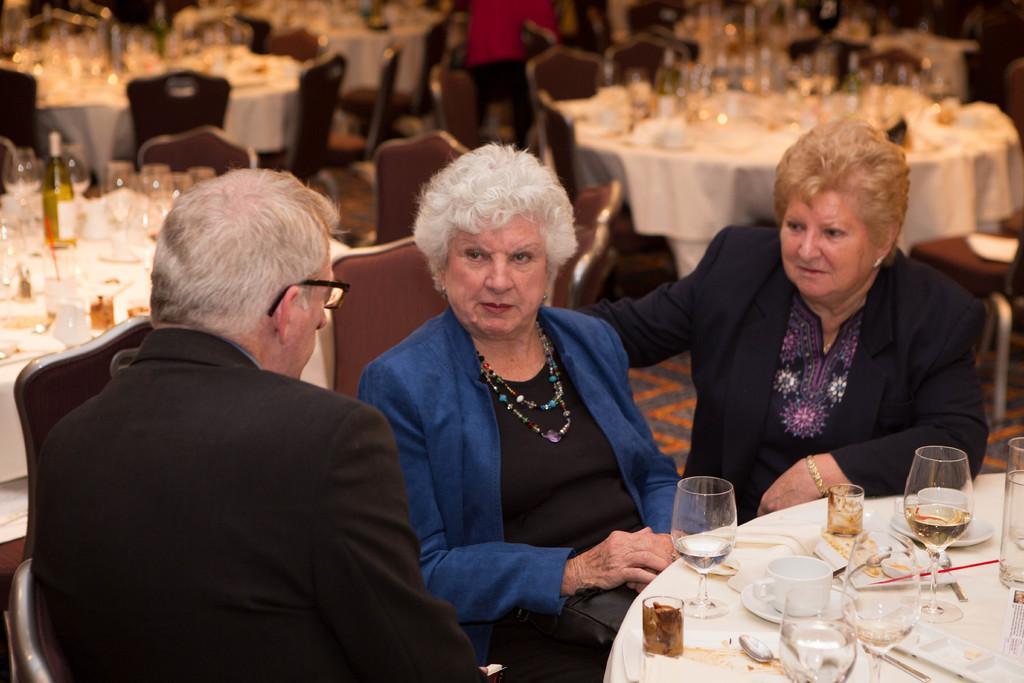Please provide a concise description of this image. In the image I can see few people siting on the chairs. I can see glasses,cups,saucers,spoons,bottle and some objects on the tables. Back I can see few chairs and few tables. 